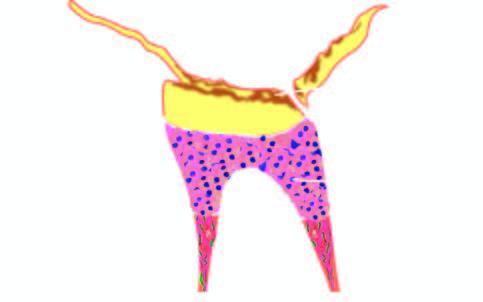what is there of secondary dentine?
Answer the question using a single word or phrase. Deposition 